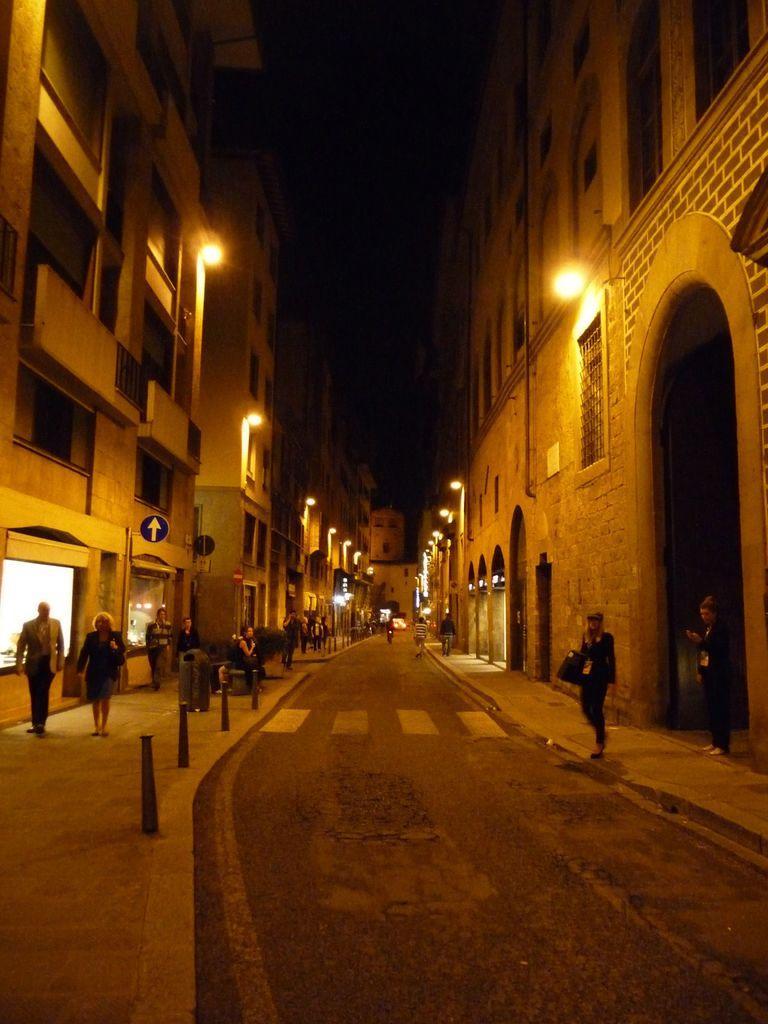Could you give a brief overview of what you see in this image? In this picture, we can see a few people on the roads, buildings with windows and some lights attached to it, poles, sign boards, and we can see the dark sky. 